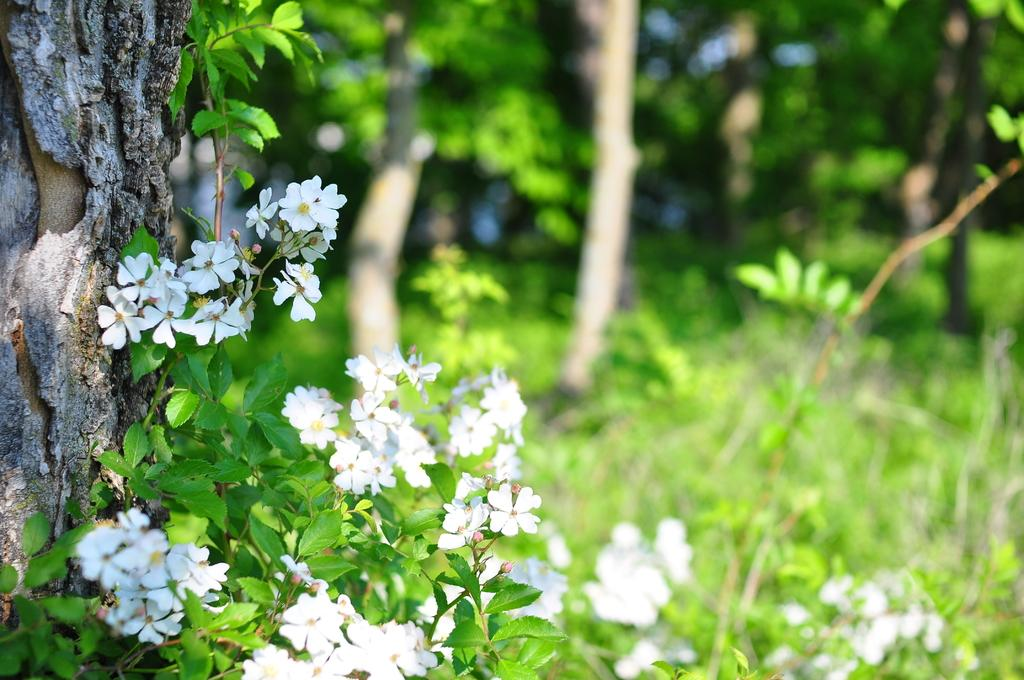What types of vegetation can be seen in the image? There are plants and flowers in the image. Can you describe the background of the image? There are trees in the background of the image. What type of yarn is being used to knit the tub in the image? There is no tub or yarn present in the image; it features plants, flowers, and trees. 